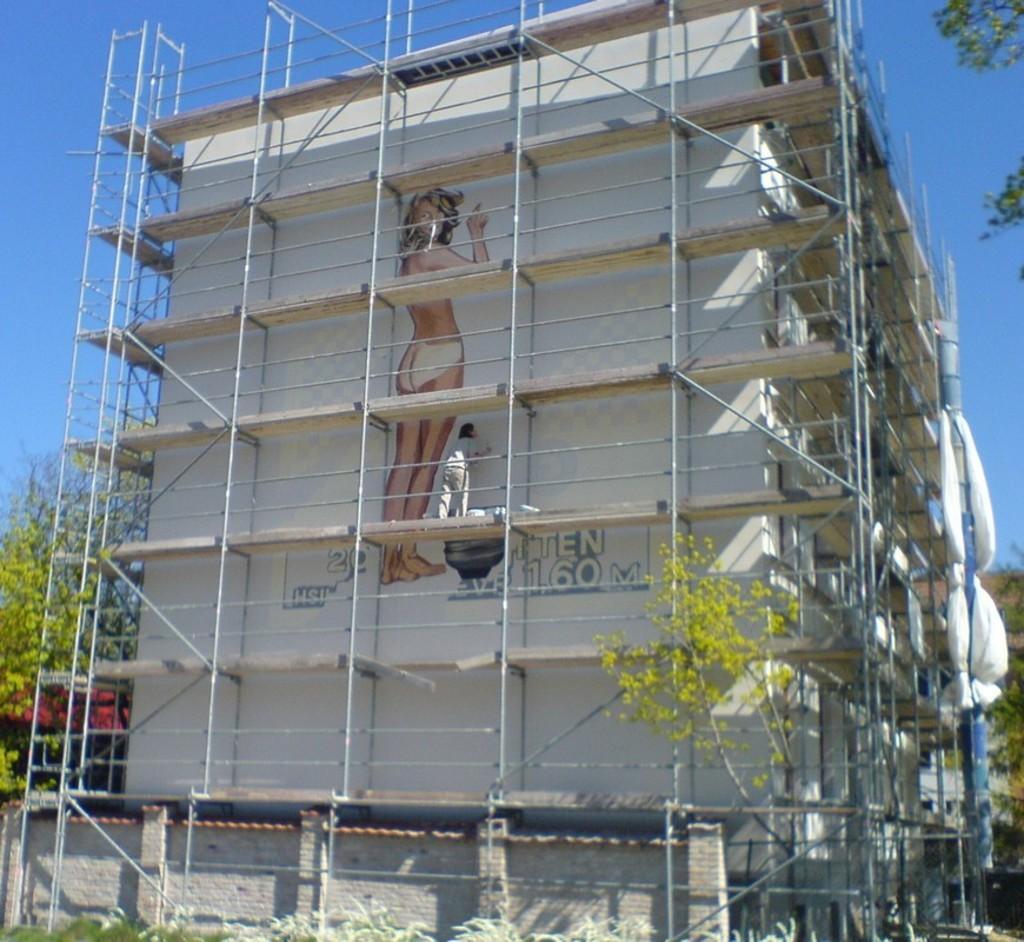Could you give a brief overview of what you see in this image? In the picture we can see a white color building and a painting of a nude woman on it and we can see a man standing near the railing and painting it and beside the building we can see some tree and in the background we can see the sky. 